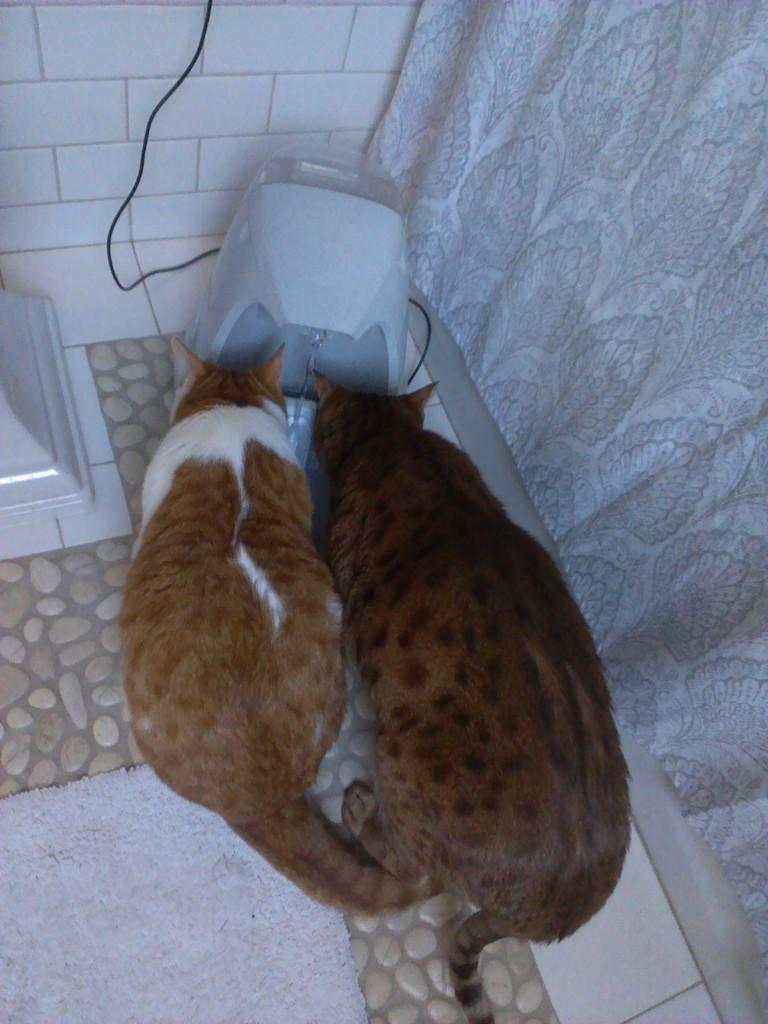Could you give a brief overview of what you see in this image? In this image there are two cats in the center, and there is some object and wire. And on the left side there is another object, on the right side there is a curtain. And in the background there is wall, at the bottom there is floor. 